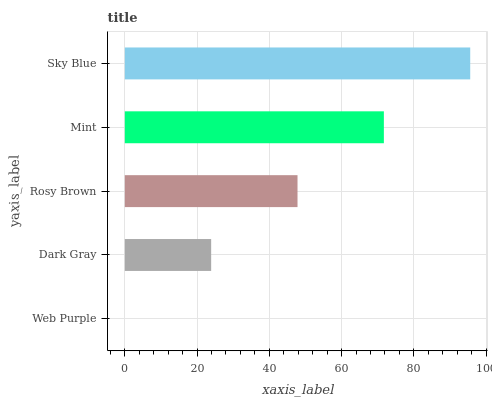Is Web Purple the minimum?
Answer yes or no. Yes. Is Sky Blue the maximum?
Answer yes or no. Yes. Is Dark Gray the minimum?
Answer yes or no. No. Is Dark Gray the maximum?
Answer yes or no. No. Is Dark Gray greater than Web Purple?
Answer yes or no. Yes. Is Web Purple less than Dark Gray?
Answer yes or no. Yes. Is Web Purple greater than Dark Gray?
Answer yes or no. No. Is Dark Gray less than Web Purple?
Answer yes or no. No. Is Rosy Brown the high median?
Answer yes or no. Yes. Is Rosy Brown the low median?
Answer yes or no. Yes. Is Sky Blue the high median?
Answer yes or no. No. Is Sky Blue the low median?
Answer yes or no. No. 